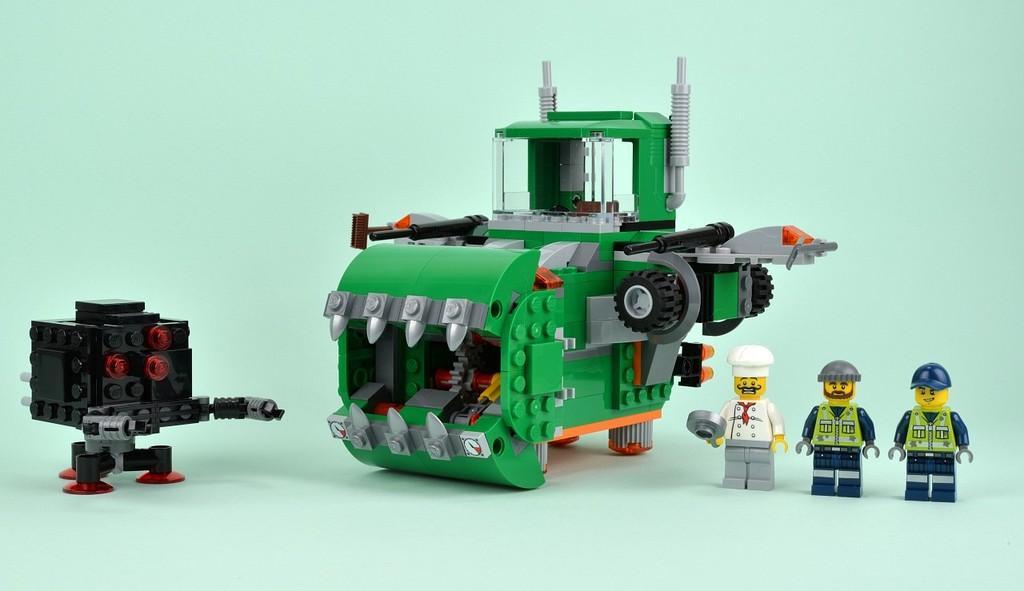In one or two sentences, can you explain what this image depicts? In this image we can see few Lego toys of people and machines. 